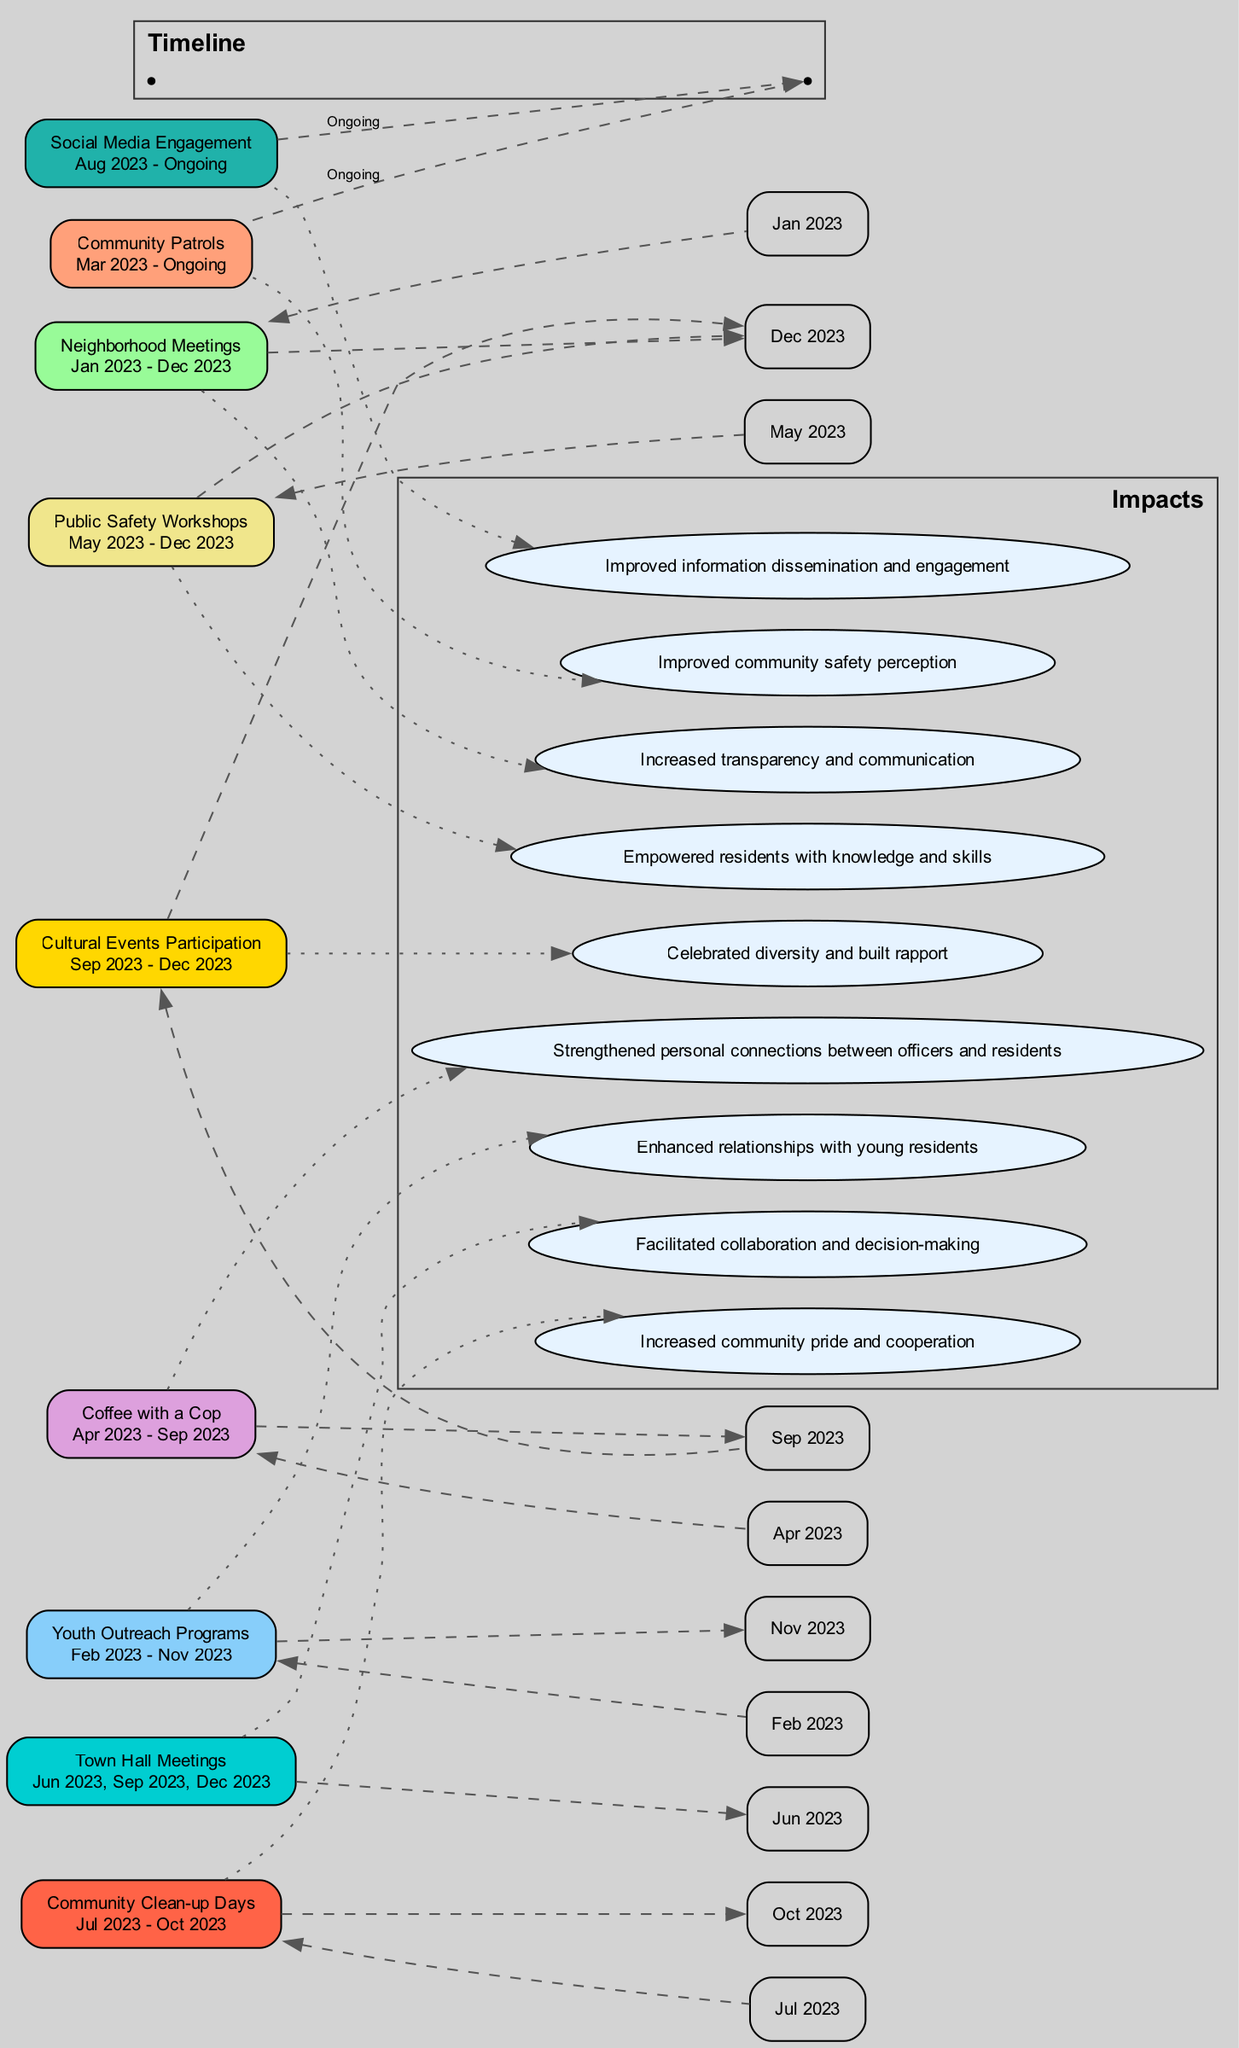What is the total number of trust-building activities listed in the diagram? The diagram lists nine distinct activities. Each activity is represented as a separate node. By counting the nodes labeled with activity names, we confirm there are nine.
Answer: 9 What activity takes place from January 2023 to December 2023? The activity "Neighborhood Meetings" is specifically noted to occur throughout the entire year 2023. The time period for this activity is explicitly mentioned as Jan 2023 - Dec 2023.
Answer: Neighborhood Meetings Which activity aims to improve community safety perception? The activity "Community Patrols" is specified as having the impact of "Improved community safety perception." This connection is direct, linking the activity node to the respective impact node.
Answer: Community Patrols In what month does the "Coffee with a Cop" activity end? The "Coffee with a Cop" activity is set to run until September 2023. Its time period is noted from April 2023 to September 2023, indicating the end month clearly.
Answer: September 2023 What is the total number of impacts listed in the diagram? The diagram features impacts tied to each activity. By counting the impact nodes connected to activities, we determine there are nine impacts corresponding to the nine activities listed.
Answer: 9 Which trust-building activity has the longest duration according to the timeline? The "Neighborhood Meetings" extend for the entire year from January to December 2023, making it the longest-running activity in the diagram. This is determined by looking at the time periods indicated for each activity.
Answer: Neighborhood Meetings What is the impact of the "Youth Outreach Programs"? The "Youth Outreach Programs" are noted to have the impact of "Enhanced relationships with young residents." This is clearly linked from the activity node to its respective impact node.
Answer: Enhanced relationships with young residents When do the "Public Safety Workshops" take place? The "Public Safety Workshops" have a duration specified from May 2023 to December 2023. The time frame is clear from the activity details provided in the diagram.
Answer: May 2023 - December 2023 How many activities have an ongoing status? There are three activities: "Community Patrols," "Social Media Engagement," and "Neighborhood Meetings" (the latter is ongoing but started earlier). This involves checking which activities have "Ongoing" included in their timelines.
Answer: 3 